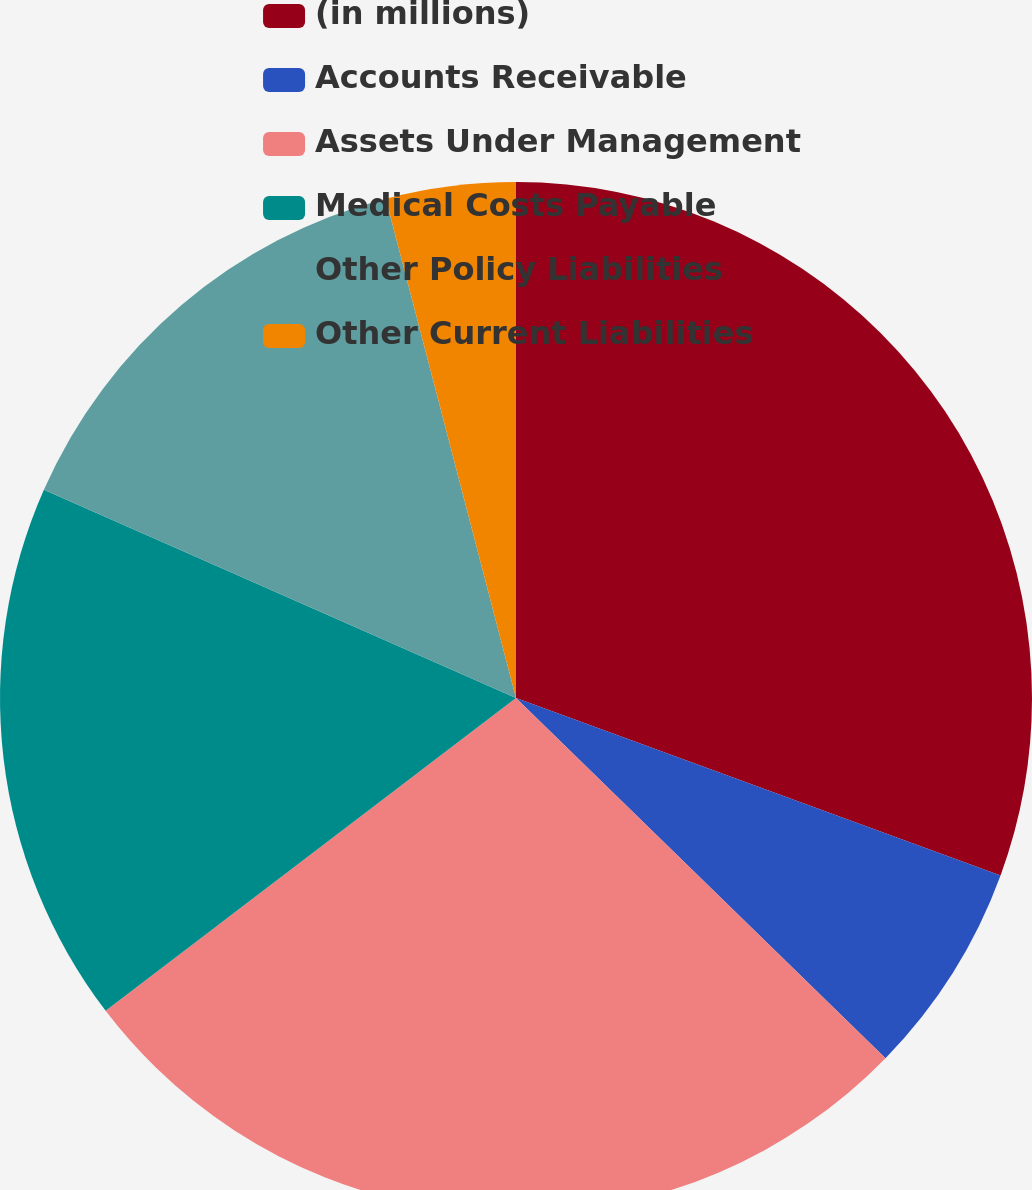<chart> <loc_0><loc_0><loc_500><loc_500><pie_chart><fcel>(in millions)<fcel>Accounts Receivable<fcel>Assets Under Management<fcel>Medical Costs Payable<fcel>Other Policy Liabilities<fcel>Other Current Liabilities<nl><fcel>30.59%<fcel>6.71%<fcel>27.34%<fcel>16.98%<fcel>14.33%<fcel>4.06%<nl></chart> 